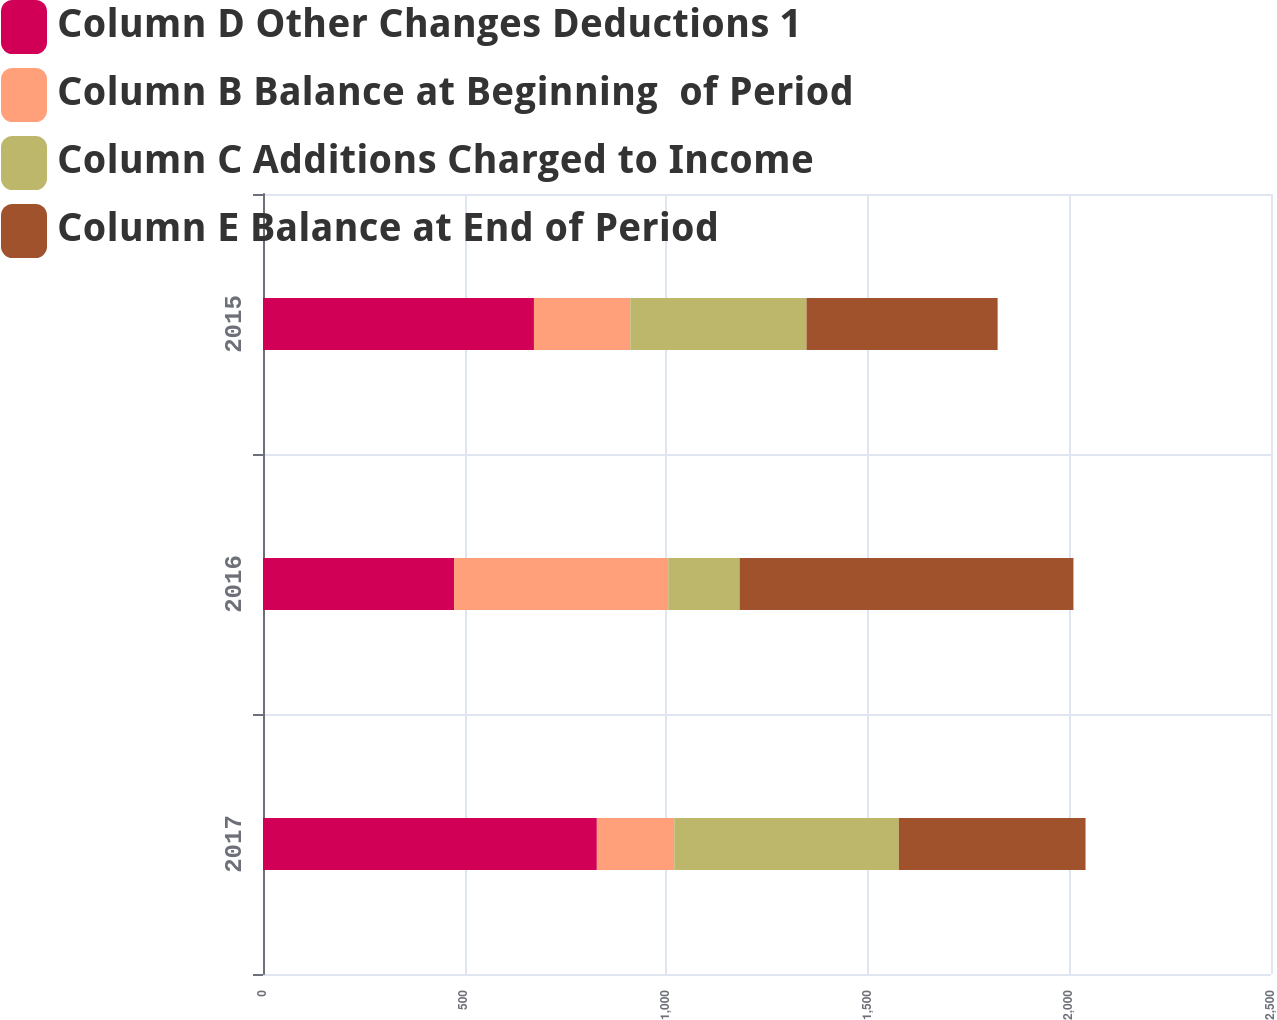<chart> <loc_0><loc_0><loc_500><loc_500><stacked_bar_chart><ecel><fcel>2017<fcel>2016<fcel>2015<nl><fcel>Column D Other Changes Deductions 1<fcel>828<fcel>474<fcel>672<nl><fcel>Column B Balance at Beginning  of Period<fcel>192<fcel>531<fcel>239<nl><fcel>Column C Additions Charged to Income<fcel>557<fcel>177<fcel>437<nl><fcel>Column E Balance at End of Period<fcel>463<fcel>828<fcel>474<nl></chart> 